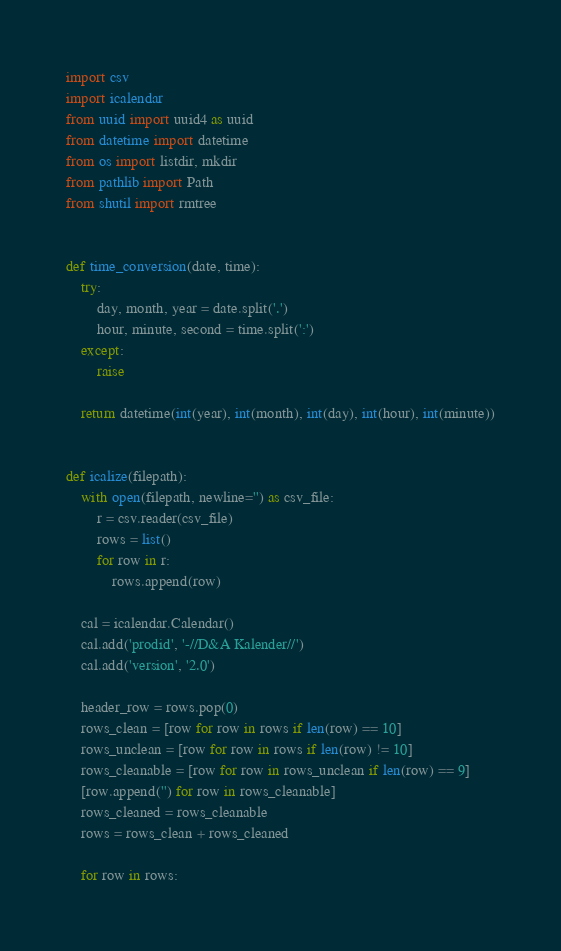<code> <loc_0><loc_0><loc_500><loc_500><_Python_>import csv
import icalendar
from uuid import uuid4 as uuid
from datetime import datetime
from os import listdir, mkdir
from pathlib import Path
from shutil import rmtree


def time_conversion(date, time):
    try:
        day, month, year = date.split('.')
        hour, minute, second = time.split(':')
    except:
        raise

    return datetime(int(year), int(month), int(day), int(hour), int(minute))


def icalize(filepath):
    with open(filepath, newline='') as csv_file:
        r = csv.reader(csv_file)
        rows = list()
        for row in r:
            rows.append(row)

    cal = icalendar.Calendar()
    cal.add('prodid', '-//D&A Kalender//')
    cal.add('version', '2.0')

    header_row = rows.pop(0)
    rows_clean = [row for row in rows if len(row) == 10]
    rows_unclean = [row for row in rows if len(row) != 10]
    rows_cleanable = [row for row in rows_unclean if len(row) == 9]
    [row.append('') for row in rows_cleanable]
    rows_cleaned = rows_cleanable
    rows = rows_clean + rows_cleaned

    for row in rows:</code> 